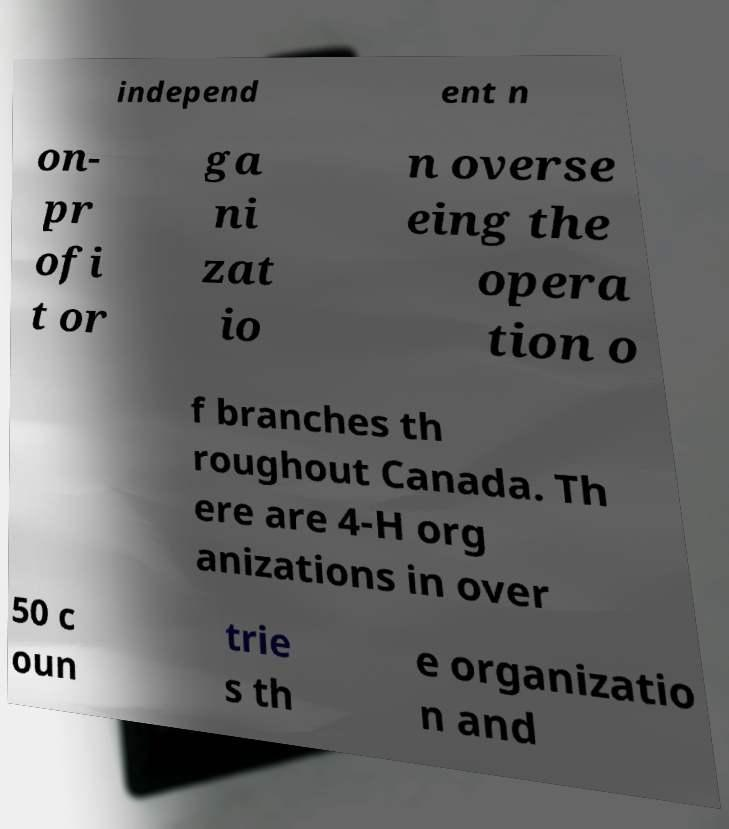Could you extract and type out the text from this image? independ ent n on- pr ofi t or ga ni zat io n overse eing the opera tion o f branches th roughout Canada. Th ere are 4-H org anizations in over 50 c oun trie s th e organizatio n and 